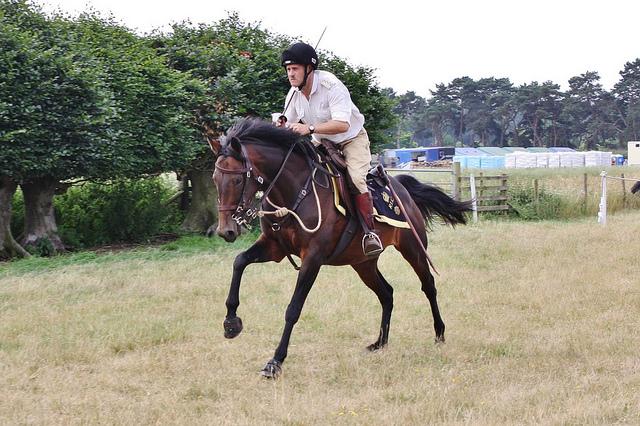Why does he have a hat on?
Answer briefly. Protection. What color is the horse's mane?
Short answer required. Black. Is that horse going backwards or forwards?
Answer briefly. Forwards. 